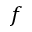Convert formula to latex. <formula><loc_0><loc_0><loc_500><loc_500>f</formula> 